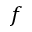Convert formula to latex. <formula><loc_0><loc_0><loc_500><loc_500>f</formula> 